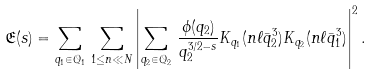Convert formula to latex. <formula><loc_0><loc_0><loc_500><loc_500>\mathfrak { E } ( s ) = \sum _ { q _ { 1 } \in \mathcal { Q } _ { 1 } } \, \sum _ { 1 \leq n \ll N } \left | \sum _ { q _ { 2 } \in \mathcal { Q } _ { 2 } } \, \frac { \phi ( q _ { 2 } ) } { q _ { 2 } ^ { 3 / 2 - s } } K _ { q _ { 1 } } ( n \ell \bar { q } _ { 2 } ^ { 3 } ) K _ { q _ { 2 } } ( n \ell \bar { q } _ { 1 } ^ { 3 } ) \right | ^ { 2 } .</formula> 